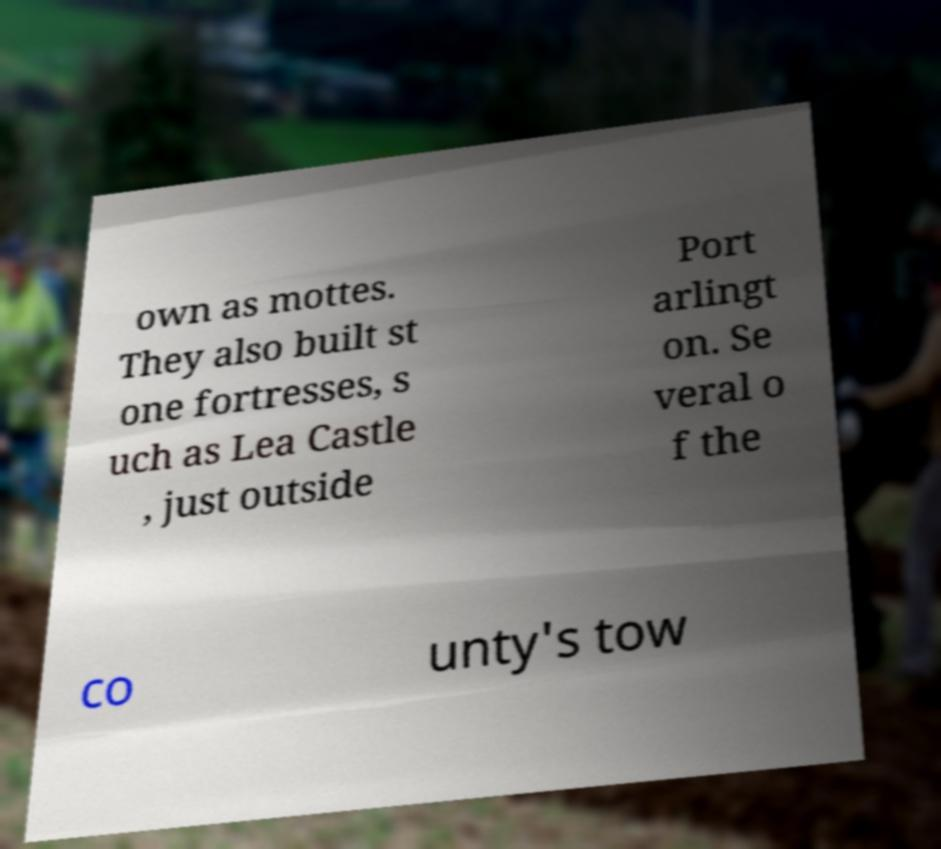Could you extract and type out the text from this image? own as mottes. They also built st one fortresses, s uch as Lea Castle , just outside Port arlingt on. Se veral o f the co unty's tow 